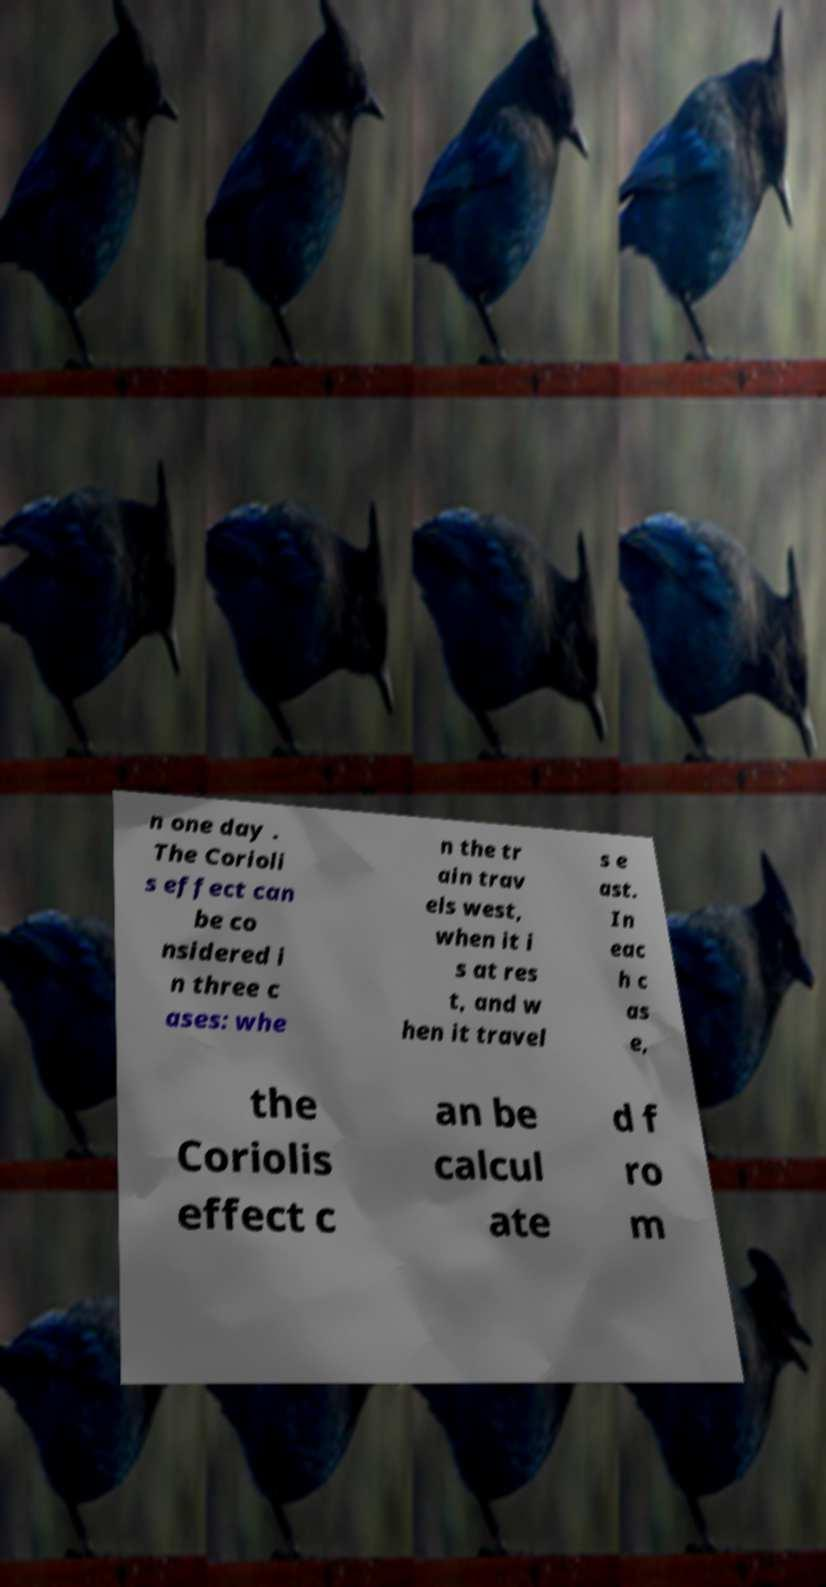There's text embedded in this image that I need extracted. Can you transcribe it verbatim? n one day . The Corioli s effect can be co nsidered i n three c ases: whe n the tr ain trav els west, when it i s at res t, and w hen it travel s e ast. In eac h c as e, the Coriolis effect c an be calcul ate d f ro m 